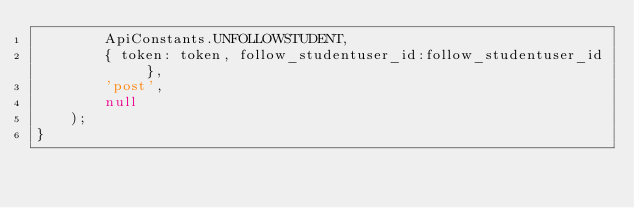Convert code to text. <code><loc_0><loc_0><loc_500><loc_500><_JavaScript_>        ApiConstants.UNFOLLOWSTUDENT,
        { token: token, follow_studentuser_id:follow_studentuser_id },        
        'post',
        null
    );
}
</code> 